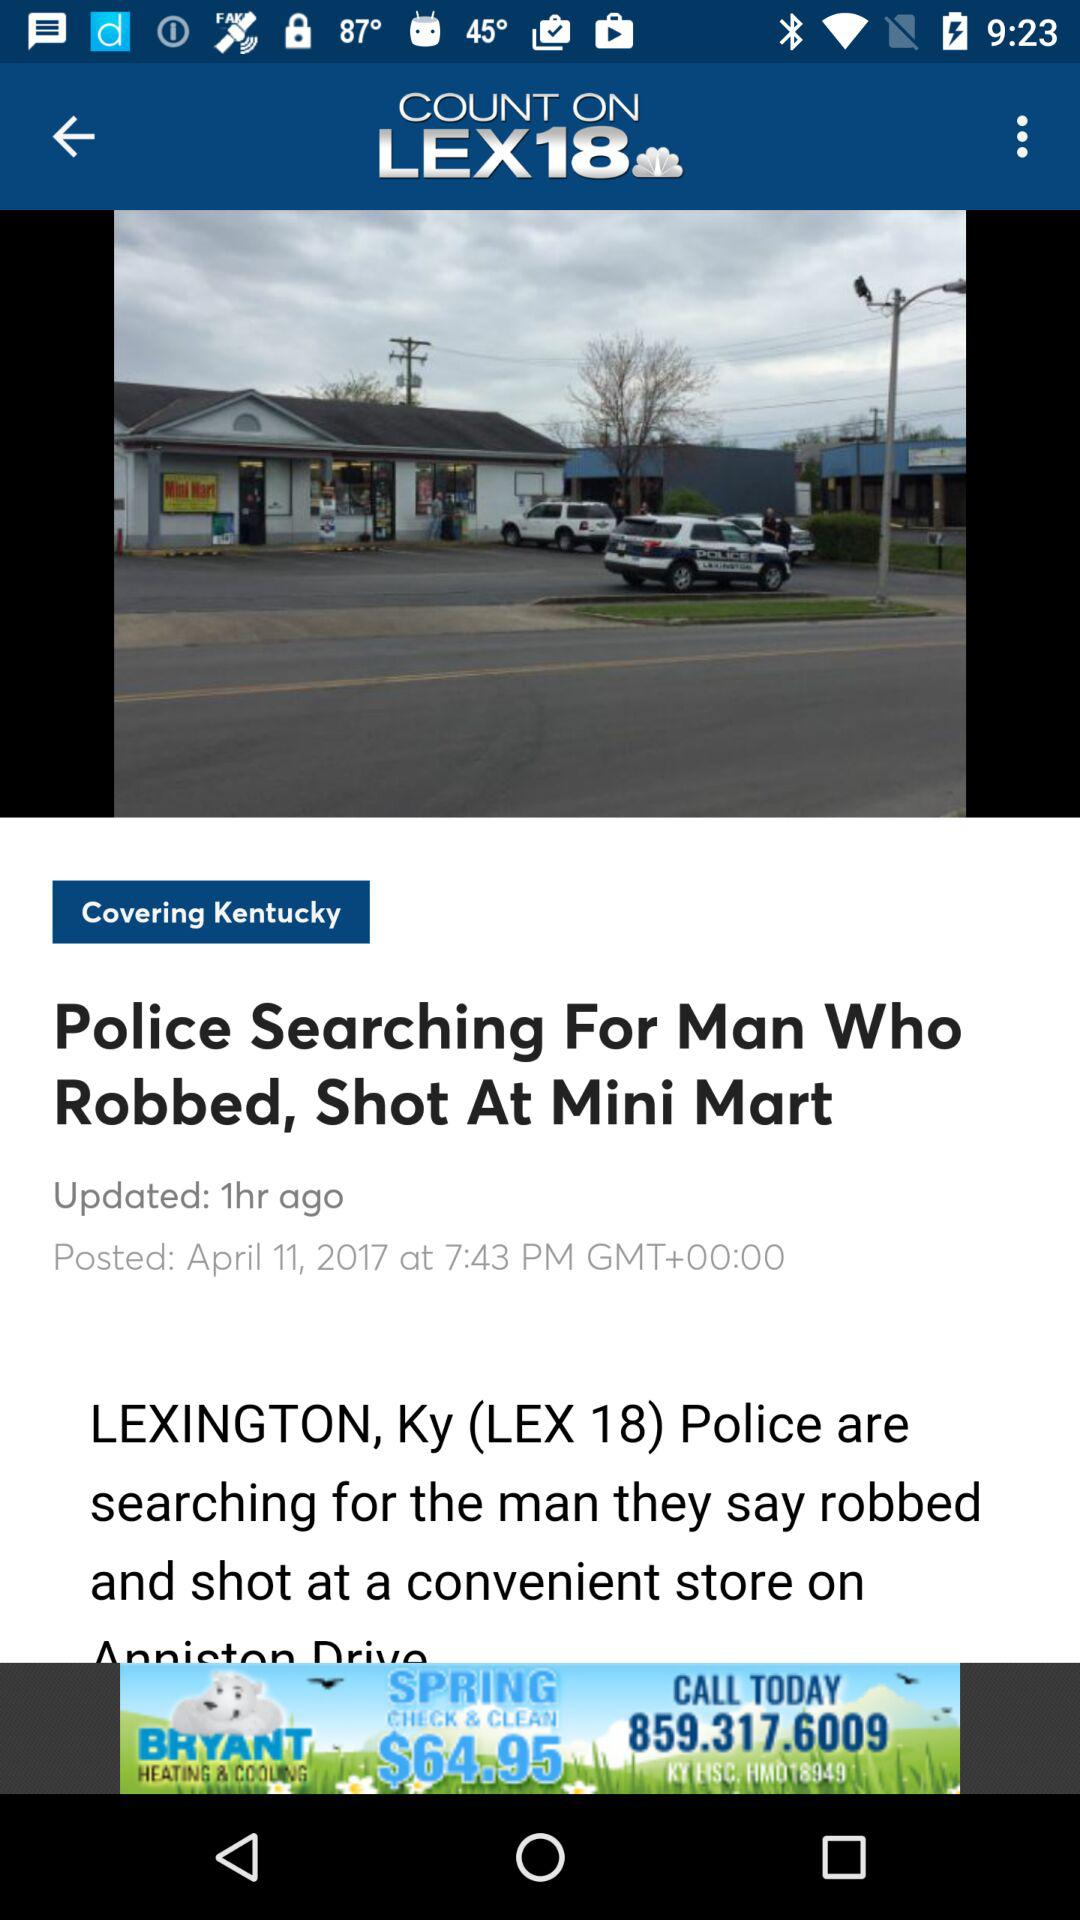What is the name of application? The name of the application is "LEX18". 